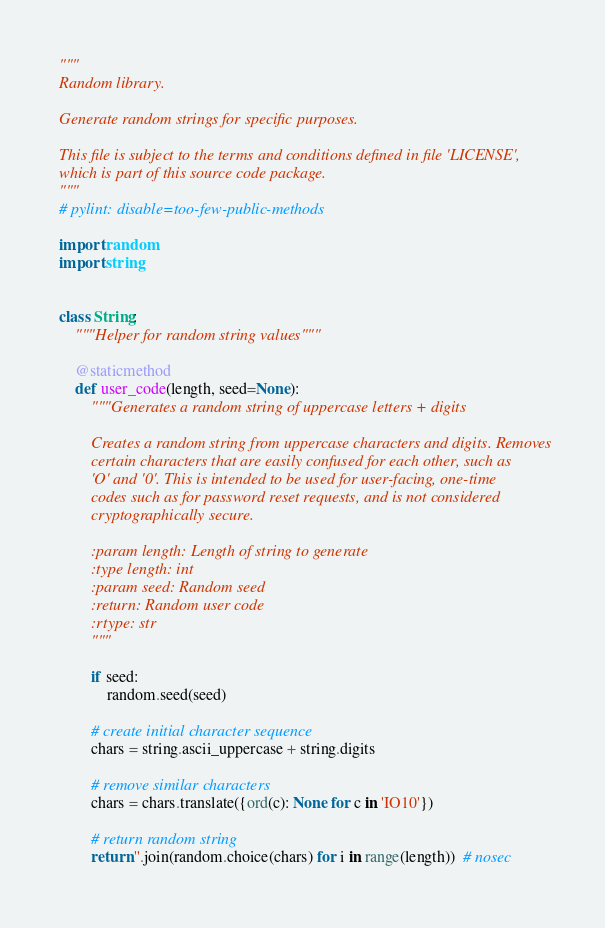<code> <loc_0><loc_0><loc_500><loc_500><_Python_>"""
Random library.

Generate random strings for specific purposes.

This file is subject to the terms and conditions defined in file 'LICENSE',
which is part of this source code package.
"""
# pylint: disable=too-few-public-methods

import random
import string


class String:
    """Helper for random string values"""

    @staticmethod
    def user_code(length, seed=None):
        """Generates a random string of uppercase letters + digits

        Creates a random string from uppercase characters and digits. Removes
        certain characters that are easily confused for each other, such as
        'O' and '0'. This is intended to be used for user-facing, one-time
        codes such as for password reset requests, and is not considered
        cryptographically secure.

        :param length: Length of string to generate
        :type length: int
        :param seed: Random seed
        :return: Random user code
        :rtype: str
        """

        if seed:
            random.seed(seed)

        # create initial character sequence
        chars = string.ascii_uppercase + string.digits

        # remove similar characters
        chars = chars.translate({ord(c): None for c in 'IO10'})

        # return random string
        return ''.join(random.choice(chars) for i in range(length))  # nosec
</code> 